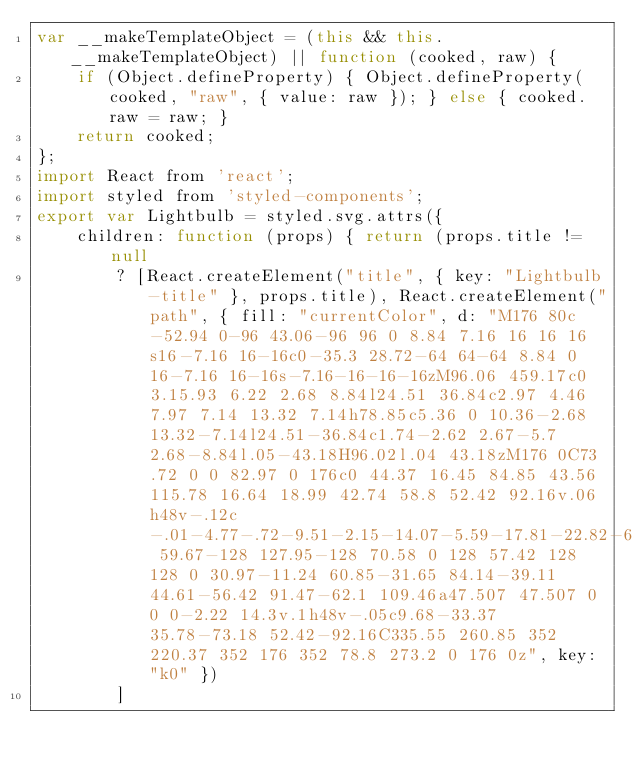Convert code to text. <code><loc_0><loc_0><loc_500><loc_500><_JavaScript_>var __makeTemplateObject = (this && this.__makeTemplateObject) || function (cooked, raw) {
    if (Object.defineProperty) { Object.defineProperty(cooked, "raw", { value: raw }); } else { cooked.raw = raw; }
    return cooked;
};
import React from 'react';
import styled from 'styled-components';
export var Lightbulb = styled.svg.attrs({
    children: function (props) { return (props.title != null
        ? [React.createElement("title", { key: "Lightbulb-title" }, props.title), React.createElement("path", { fill: "currentColor", d: "M176 80c-52.94 0-96 43.06-96 96 0 8.84 7.16 16 16 16s16-7.16 16-16c0-35.3 28.72-64 64-64 8.84 0 16-7.16 16-16s-7.16-16-16-16zM96.06 459.17c0 3.15.93 6.22 2.68 8.84l24.51 36.84c2.97 4.46 7.97 7.14 13.32 7.14h78.85c5.36 0 10.36-2.68 13.32-7.14l24.51-36.84c1.74-2.62 2.67-5.7 2.68-8.84l.05-43.18H96.02l.04 43.18zM176 0C73.72 0 0 82.97 0 176c0 44.37 16.45 84.85 43.56 115.78 16.64 18.99 42.74 58.8 52.42 92.16v.06h48v-.12c-.01-4.77-.72-9.51-2.15-14.07-5.59-17.81-22.82-64.77-62.17-109.67-20.54-23.43-31.52-53.15-31.61-84.14-.2-73.64 59.67-128 127.95-128 70.58 0 128 57.42 128 128 0 30.97-11.24 60.85-31.65 84.14-39.11 44.61-56.42 91.47-62.1 109.46a47.507 47.507 0 0 0-2.22 14.3v.1h48v-.05c9.68-33.37 35.78-73.18 52.42-92.16C335.55 260.85 352 220.37 352 176 352 78.8 273.2 0 176 0z", key: "k0" })
        ]</code> 